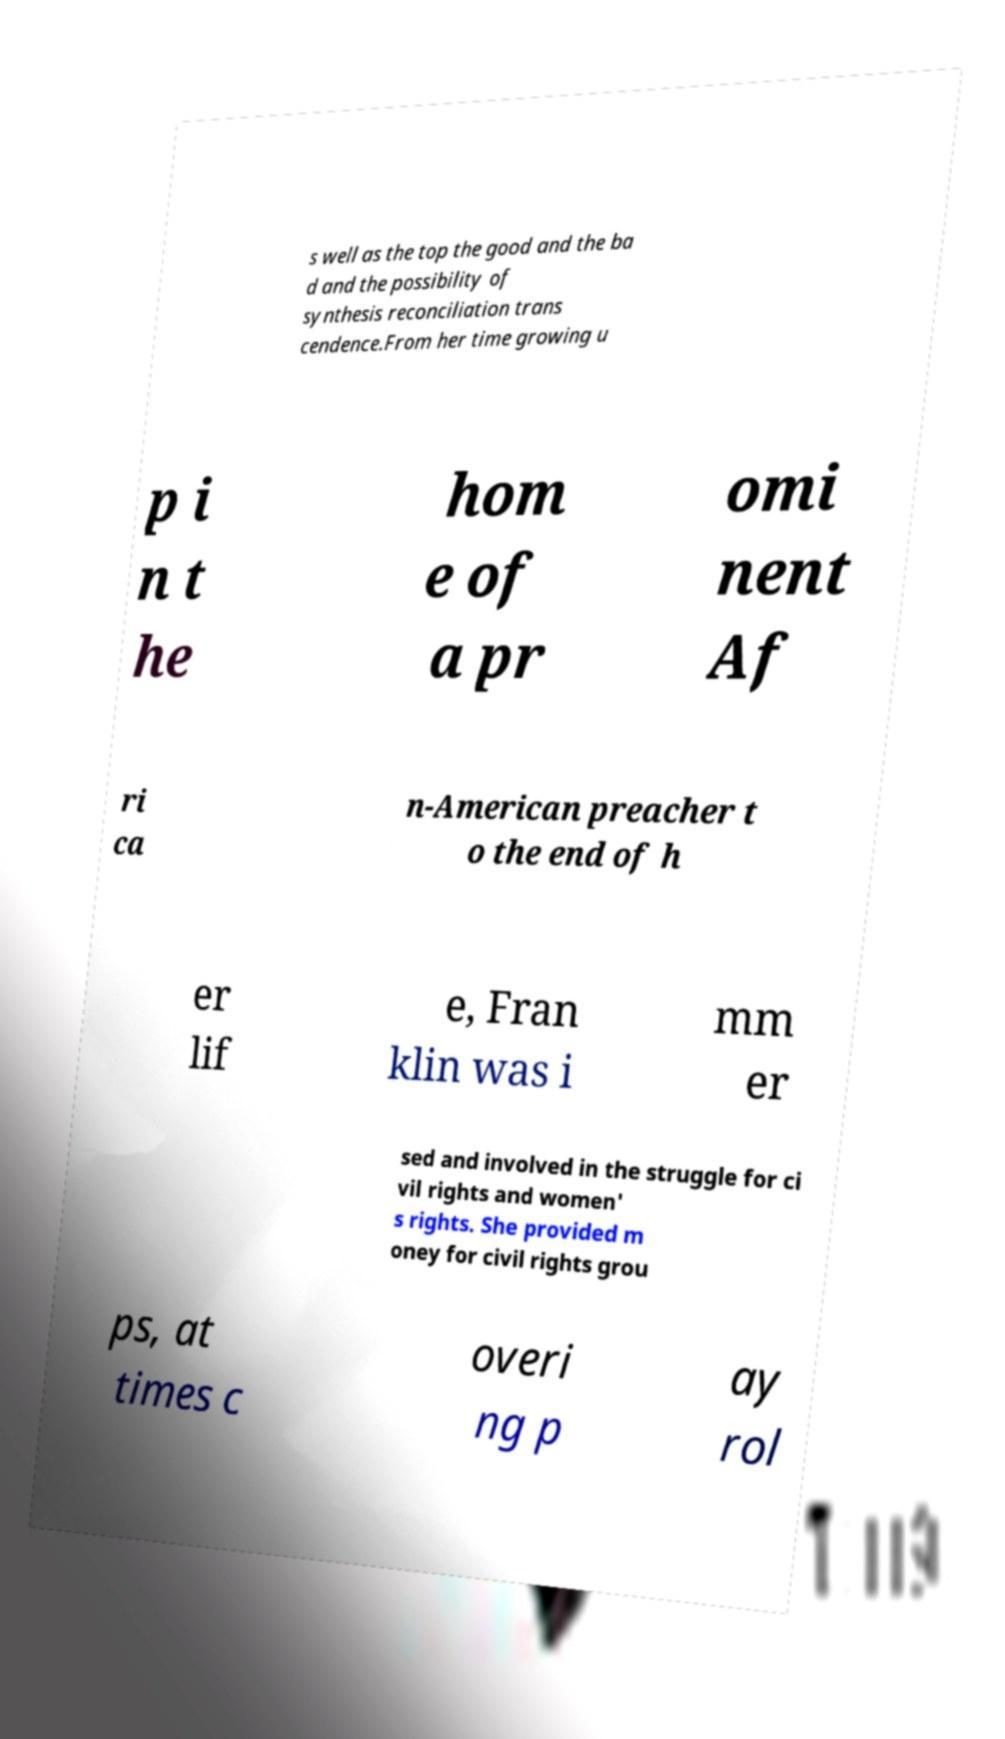For documentation purposes, I need the text within this image transcribed. Could you provide that? s well as the top the good and the ba d and the possibility of synthesis reconciliation trans cendence.From her time growing u p i n t he hom e of a pr omi nent Af ri ca n-American preacher t o the end of h er lif e, Fran klin was i mm er sed and involved in the struggle for ci vil rights and women' s rights. She provided m oney for civil rights grou ps, at times c overi ng p ay rol 